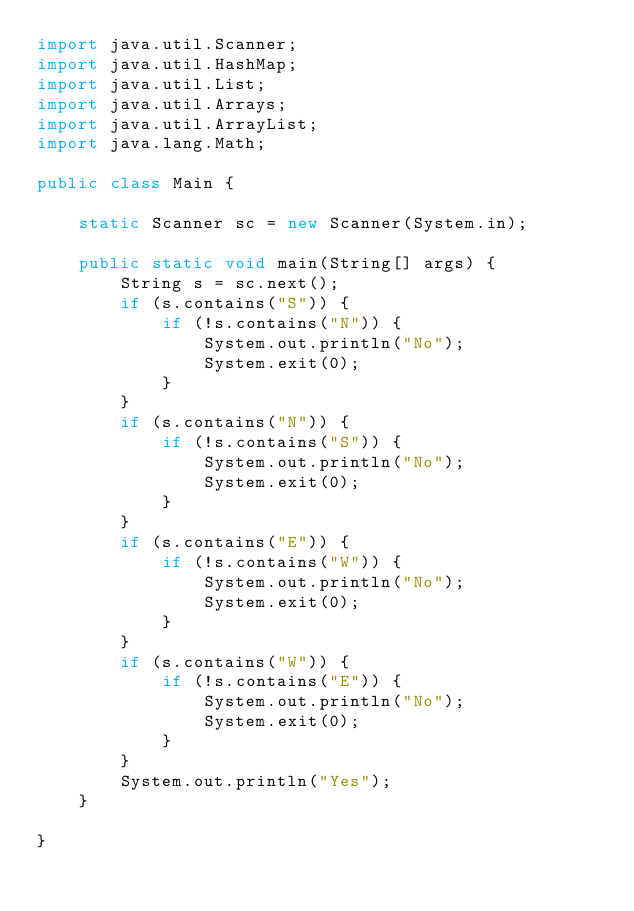Convert code to text. <code><loc_0><loc_0><loc_500><loc_500><_Java_>import java.util.Scanner;
import java.util.HashMap;
import java.util.List;
import java.util.Arrays;
import java.util.ArrayList;
import java.lang.Math;

public class Main {

    static Scanner sc = new Scanner(System.in);

    public static void main(String[] args) {
        String s = sc.next();
        if (s.contains("S")) {
            if (!s.contains("N")) {
                System.out.println("No");
                System.exit(0);
            }
        }
        if (s.contains("N")) {
            if (!s.contains("S")) {
                System.out.println("No");
                System.exit(0);
            }
        }
        if (s.contains("E")) {
            if (!s.contains("W")) {
                System.out.println("No");
                System.exit(0);
            }
        }
        if (s.contains("W")) {
            if (!s.contains("E")) {
                System.out.println("No");
                System.exit(0);
            }
        }
        System.out.println("Yes");
    }

}
</code> 